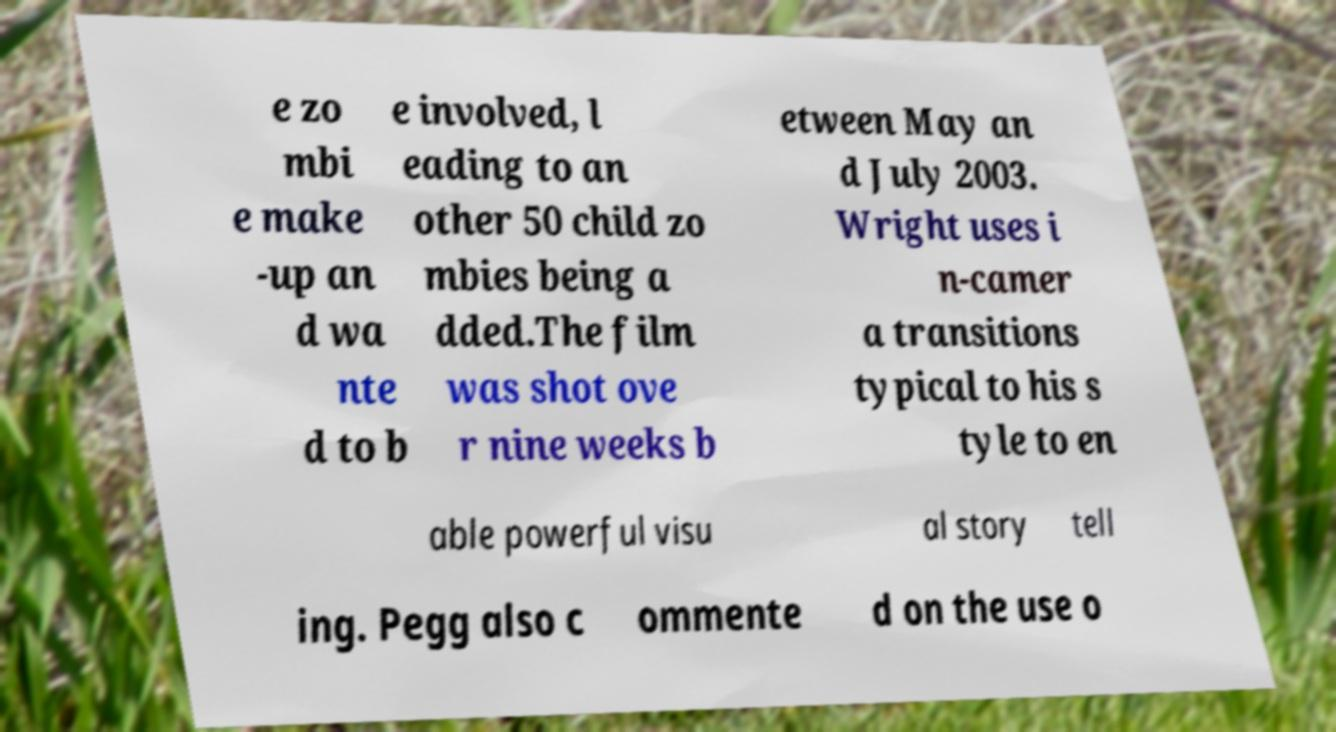I need the written content from this picture converted into text. Can you do that? e zo mbi e make -up an d wa nte d to b e involved, l eading to an other 50 child zo mbies being a dded.The film was shot ove r nine weeks b etween May an d July 2003. Wright uses i n-camer a transitions typical to his s tyle to en able powerful visu al story tell ing. Pegg also c ommente d on the use o 